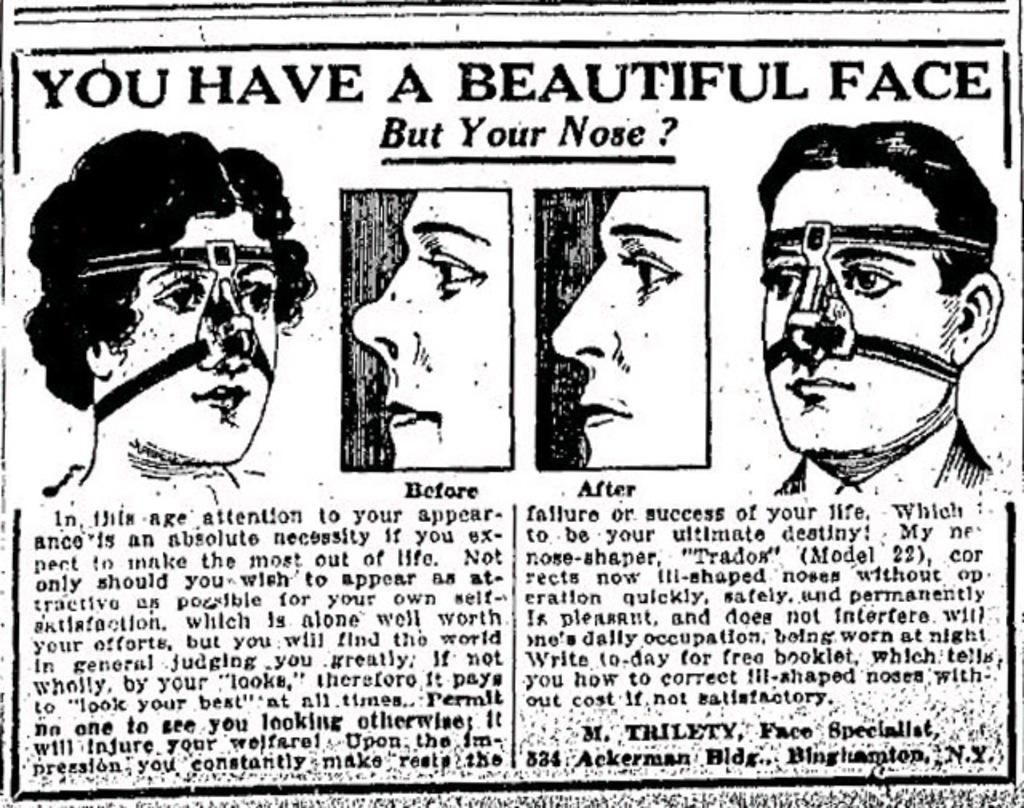What is the main subject of the image? The main subject of the image is an article. What type of content is included in the article? The article contains images of faces. Is there any text on the article? Yes, there is writing on the article. What type of needle is being used by the fireman in the image? There is no fireman or needle present in the image; it features an article with images of faces and writing. 